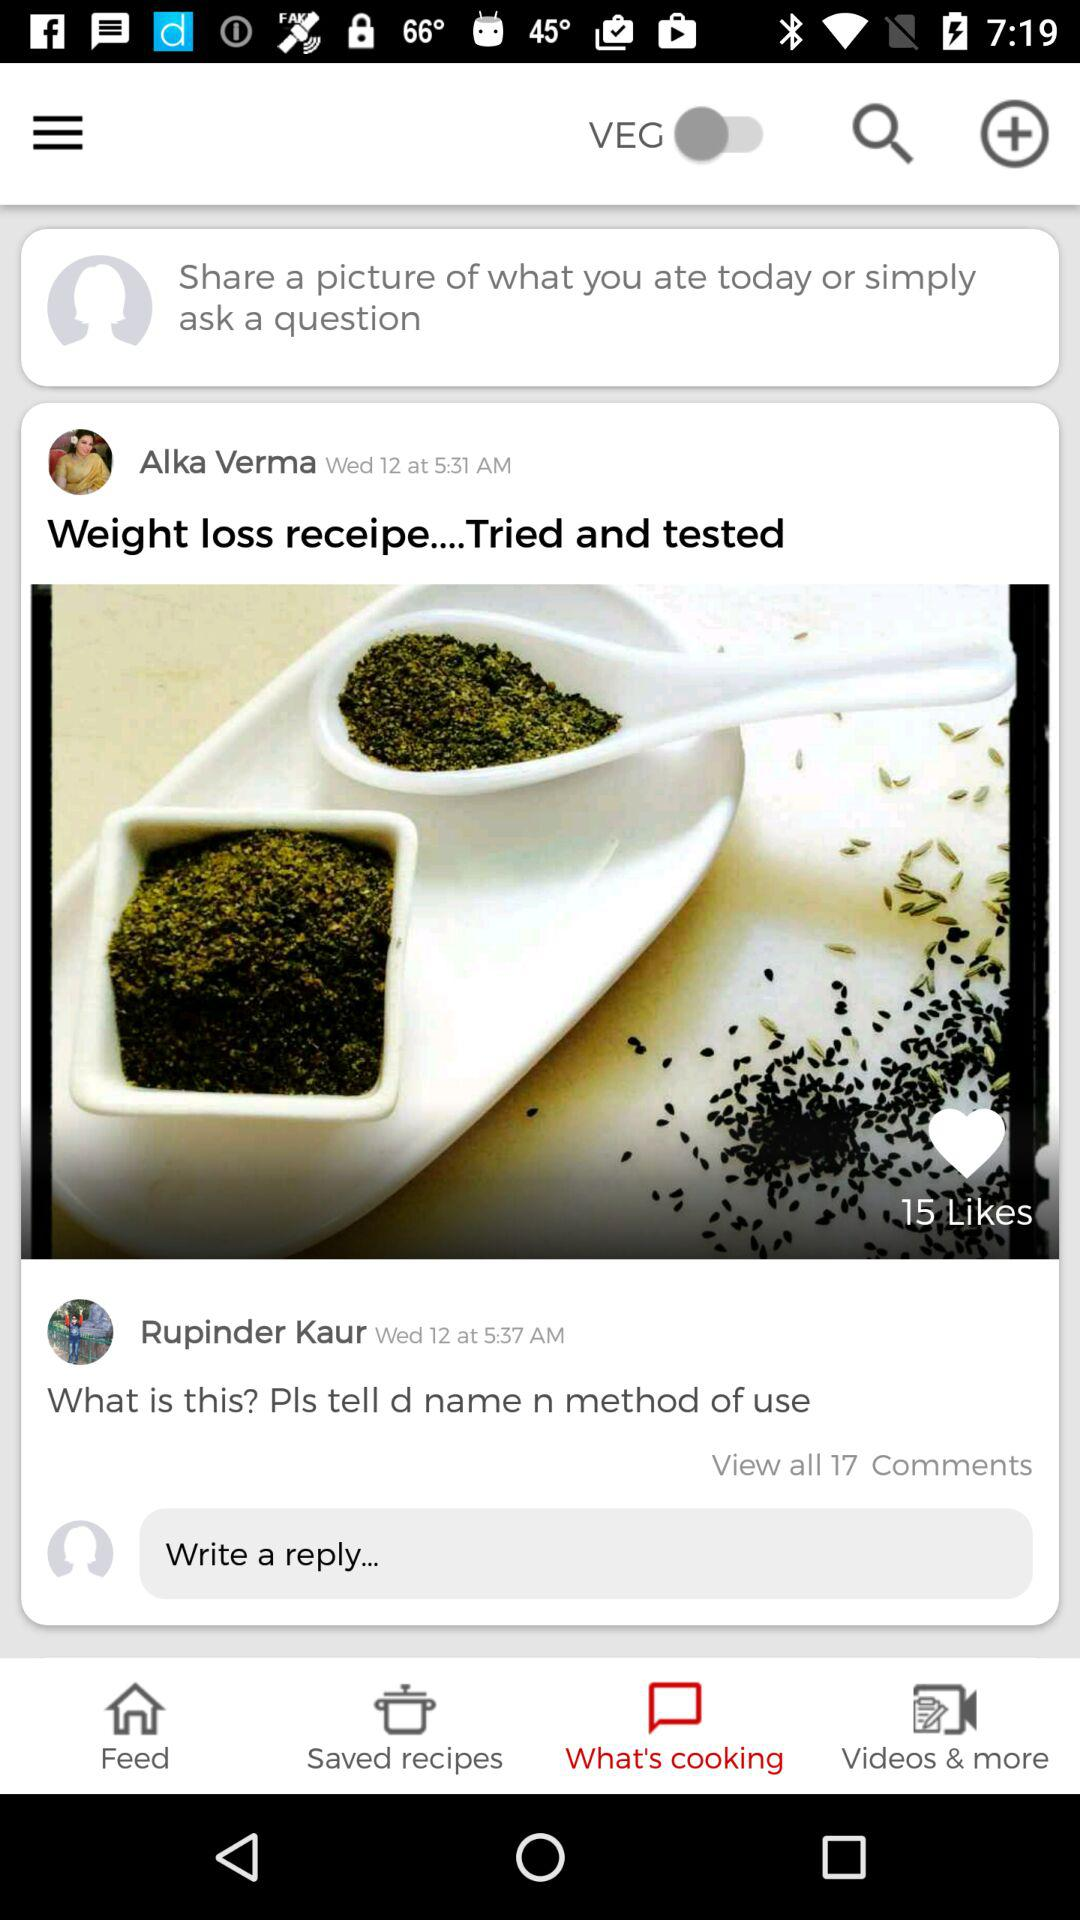How many comments does the first post have?
Answer the question using a single word or phrase. 17 